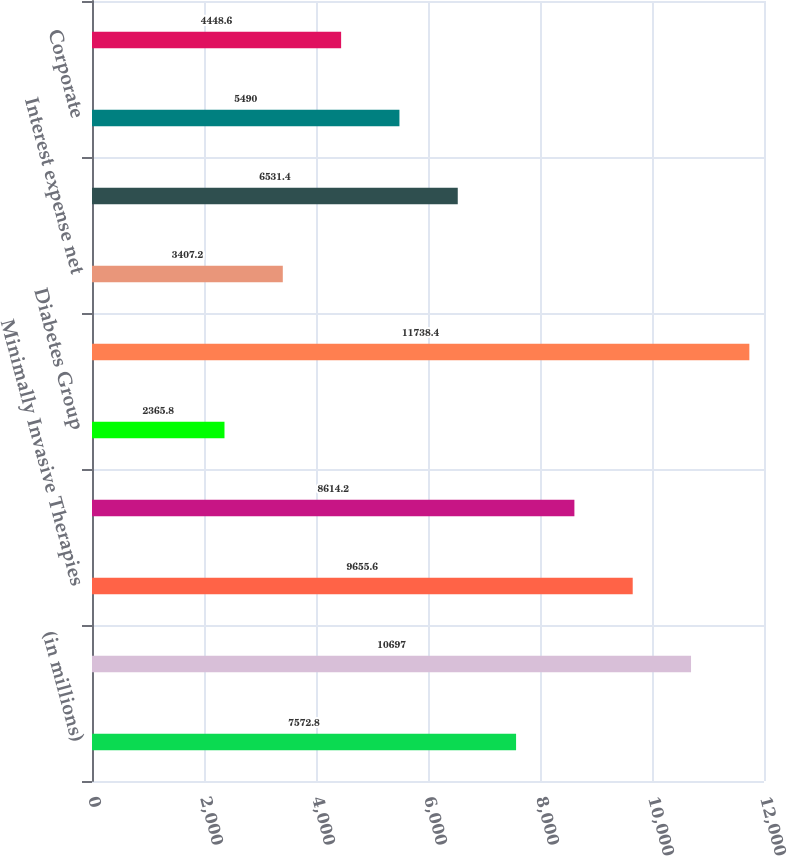<chart> <loc_0><loc_0><loc_500><loc_500><bar_chart><fcel>(in millions)<fcel>Cardiac and Vascular Group<fcel>Minimally Invasive Therapies<fcel>Restorative Therapies Group<fcel>Diabetes Group<fcel>Segment EBITA<fcel>Interest expense net<fcel>Amortization of intangible<fcel>Corporate<fcel>Centralized distribution costs<nl><fcel>7572.8<fcel>10697<fcel>9655.6<fcel>8614.2<fcel>2365.8<fcel>11738.4<fcel>3407.2<fcel>6531.4<fcel>5490<fcel>4448.6<nl></chart> 